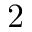Convert formula to latex. <formula><loc_0><loc_0><loc_500><loc_500>2</formula> 